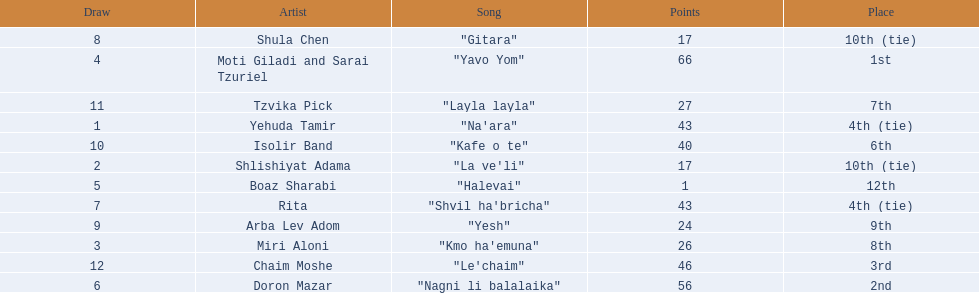How many artists are there? Yehuda Tamir, Shlishiyat Adama, Miri Aloni, Moti Giladi and Sarai Tzuriel, Boaz Sharabi, Doron Mazar, Rita, Shula Chen, Arba Lev Adom, Isolir Band, Tzvika Pick, Chaim Moshe. What is the least amount of points awarded? 1. Who was the artist awarded those points? Boaz Sharabi. 